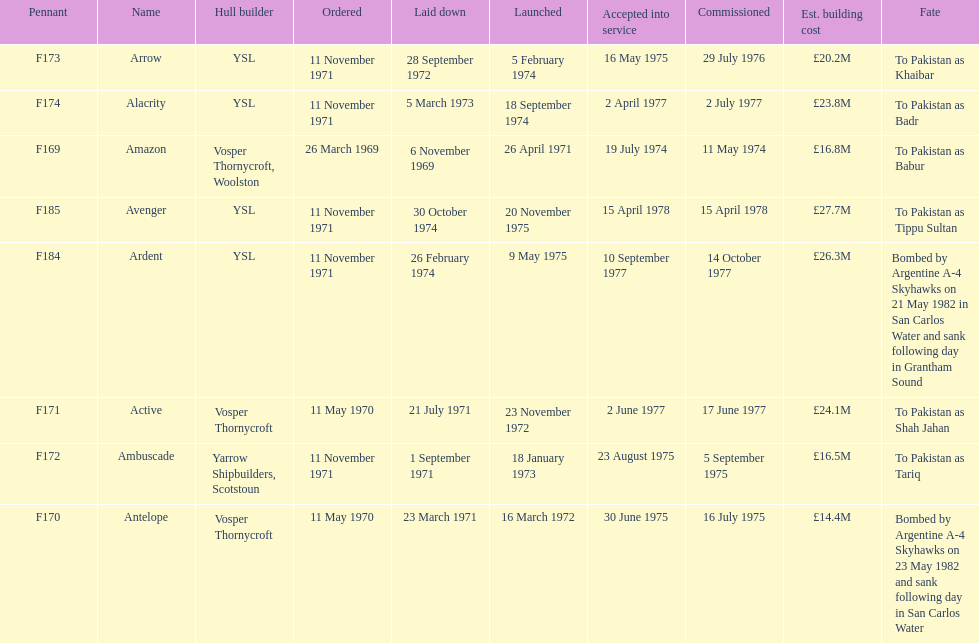How many ships were built after ardent? 1. 